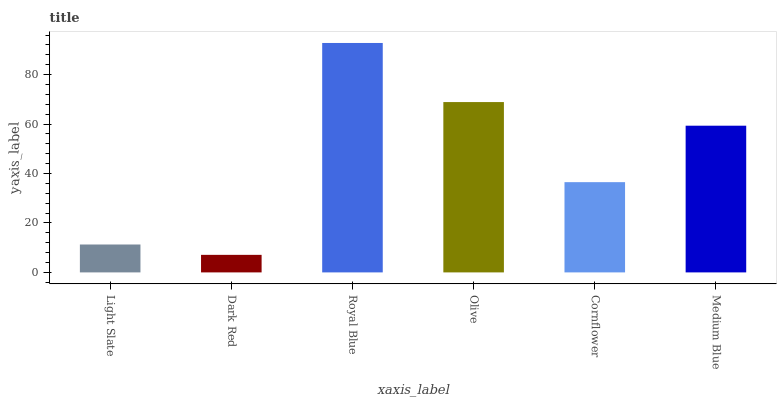Is Dark Red the minimum?
Answer yes or no. Yes. Is Royal Blue the maximum?
Answer yes or no. Yes. Is Royal Blue the minimum?
Answer yes or no. No. Is Dark Red the maximum?
Answer yes or no. No. Is Royal Blue greater than Dark Red?
Answer yes or no. Yes. Is Dark Red less than Royal Blue?
Answer yes or no. Yes. Is Dark Red greater than Royal Blue?
Answer yes or no. No. Is Royal Blue less than Dark Red?
Answer yes or no. No. Is Medium Blue the high median?
Answer yes or no. Yes. Is Cornflower the low median?
Answer yes or no. Yes. Is Royal Blue the high median?
Answer yes or no. No. Is Olive the low median?
Answer yes or no. No. 